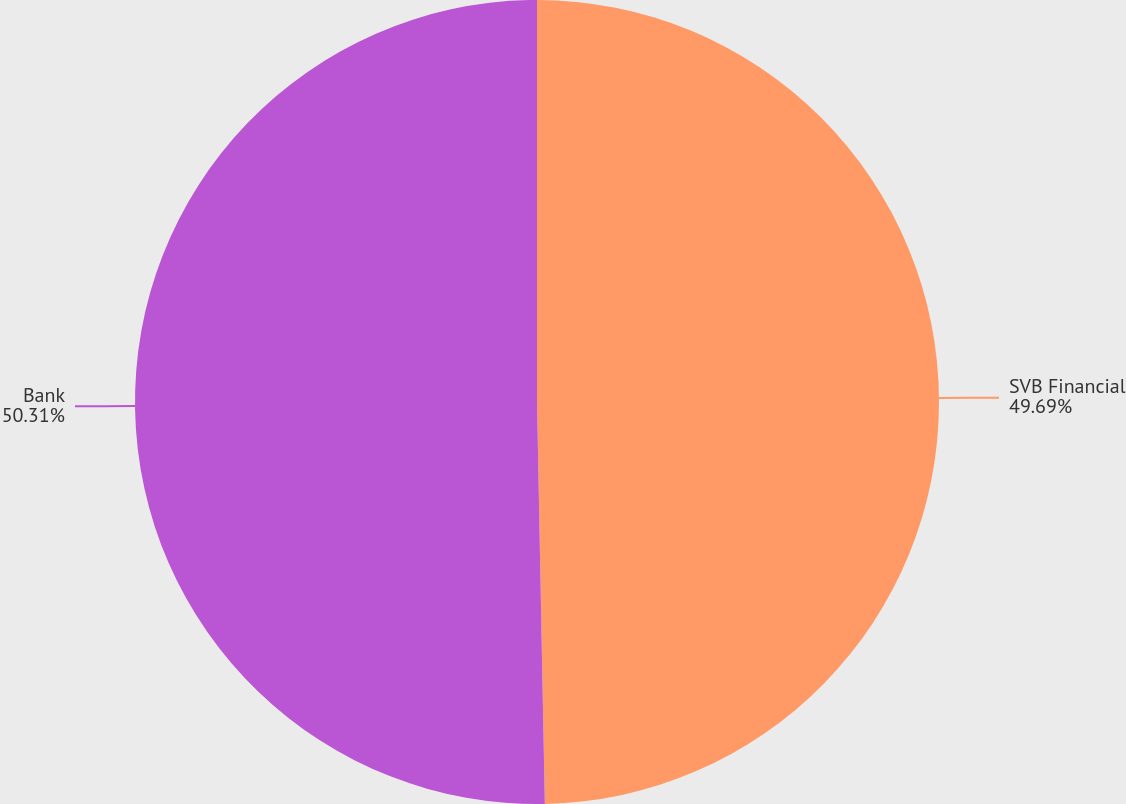Convert chart. <chart><loc_0><loc_0><loc_500><loc_500><pie_chart><fcel>SVB Financial<fcel>Bank<nl><fcel>49.69%<fcel>50.31%<nl></chart> 